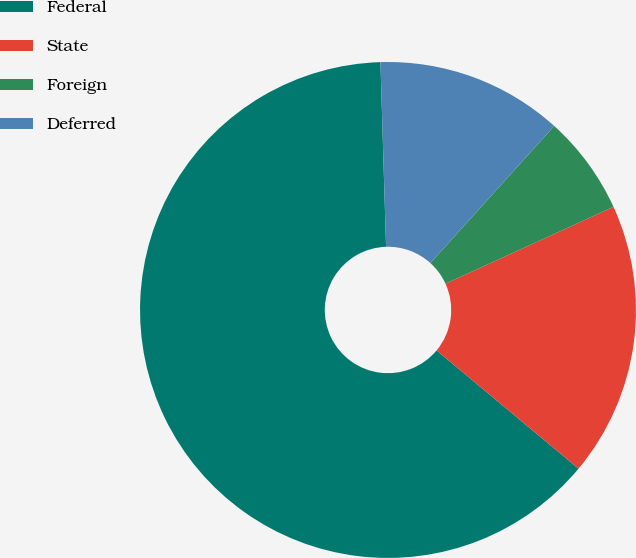Convert chart. <chart><loc_0><loc_0><loc_500><loc_500><pie_chart><fcel>Federal<fcel>State<fcel>Foreign<fcel>Deferred<nl><fcel>63.47%<fcel>17.88%<fcel>6.48%<fcel>12.18%<nl></chart> 